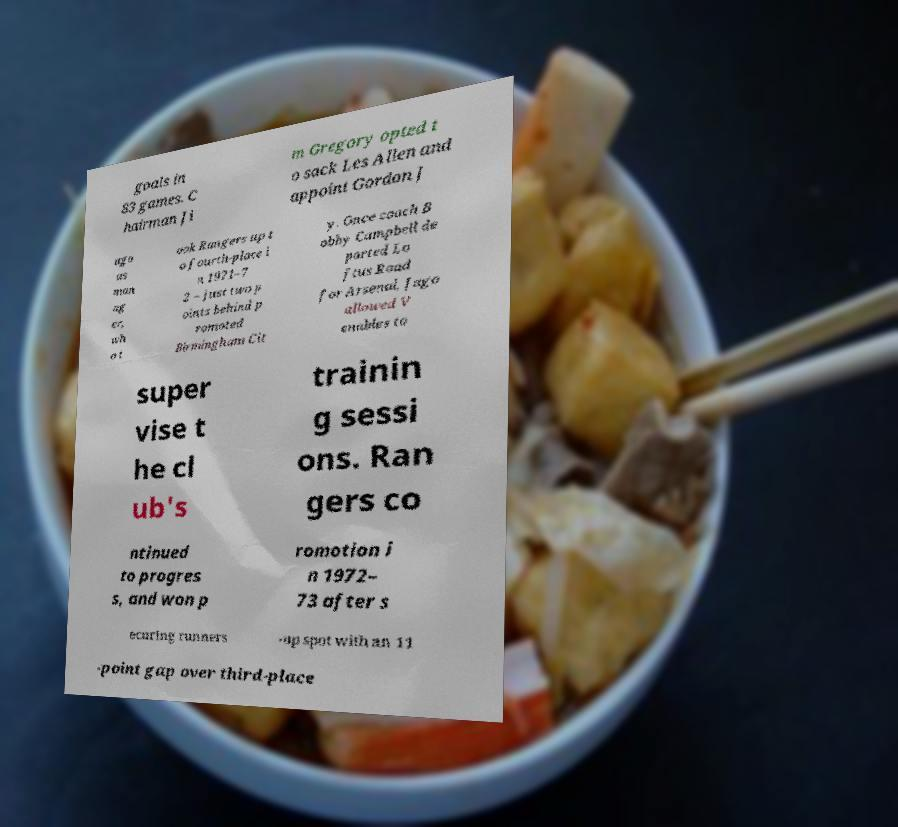Could you assist in decoding the text presented in this image and type it out clearly? goals in 83 games. C hairman Ji m Gregory opted t o sack Les Allen and appoint Gordon J ago as man ag er, wh o t ook Rangers up t o fourth-place i n 1971–7 2 – just two p oints behind p romoted Birmingham Cit y. Once coach B obby Campbell de parted Lo ftus Road for Arsenal, Jago allowed V enables to super vise t he cl ub's trainin g sessi ons. Ran gers co ntinued to progres s, and won p romotion i n 1972– 73 after s ecuring runners -up spot with an 11 -point gap over third-place 